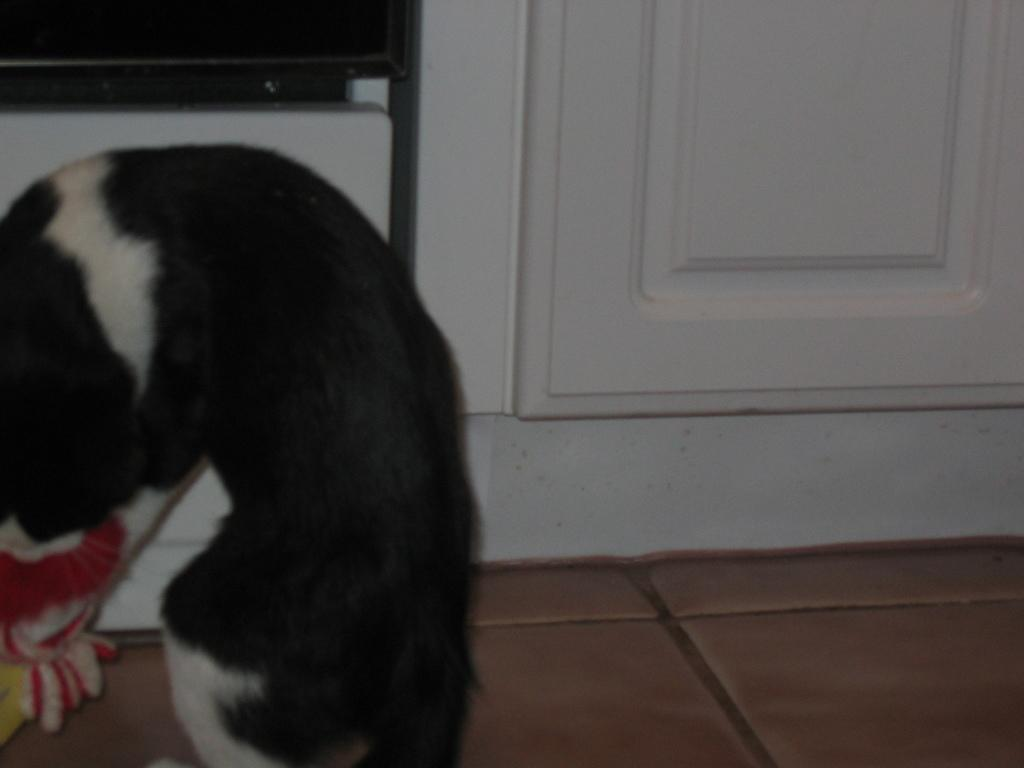What is the main subject in the foreground of the image? There is a dog in the foreground of the image. Where is the dog located in relation to the image? The dog is on the left side of the image. What surface is the dog on? The dog is on the floor. What can be seen in the background of the image? There is a wall in the background of the image. What is visible at the top of the image? There is a screen visible at the top of the image. What type of notebook is the dog holding in the image? There is no notebook present in the image; the dog is not holding anything. What kind of lumber is visible in the image? There is no lumber present in the image. 